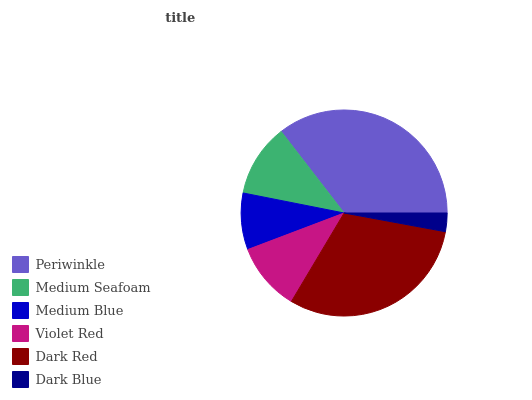Is Dark Blue the minimum?
Answer yes or no. Yes. Is Periwinkle the maximum?
Answer yes or no. Yes. Is Medium Seafoam the minimum?
Answer yes or no. No. Is Medium Seafoam the maximum?
Answer yes or no. No. Is Periwinkle greater than Medium Seafoam?
Answer yes or no. Yes. Is Medium Seafoam less than Periwinkle?
Answer yes or no. Yes. Is Medium Seafoam greater than Periwinkle?
Answer yes or no. No. Is Periwinkle less than Medium Seafoam?
Answer yes or no. No. Is Medium Seafoam the high median?
Answer yes or no. Yes. Is Violet Red the low median?
Answer yes or no. Yes. Is Dark Blue the high median?
Answer yes or no. No. Is Medium Seafoam the low median?
Answer yes or no. No. 